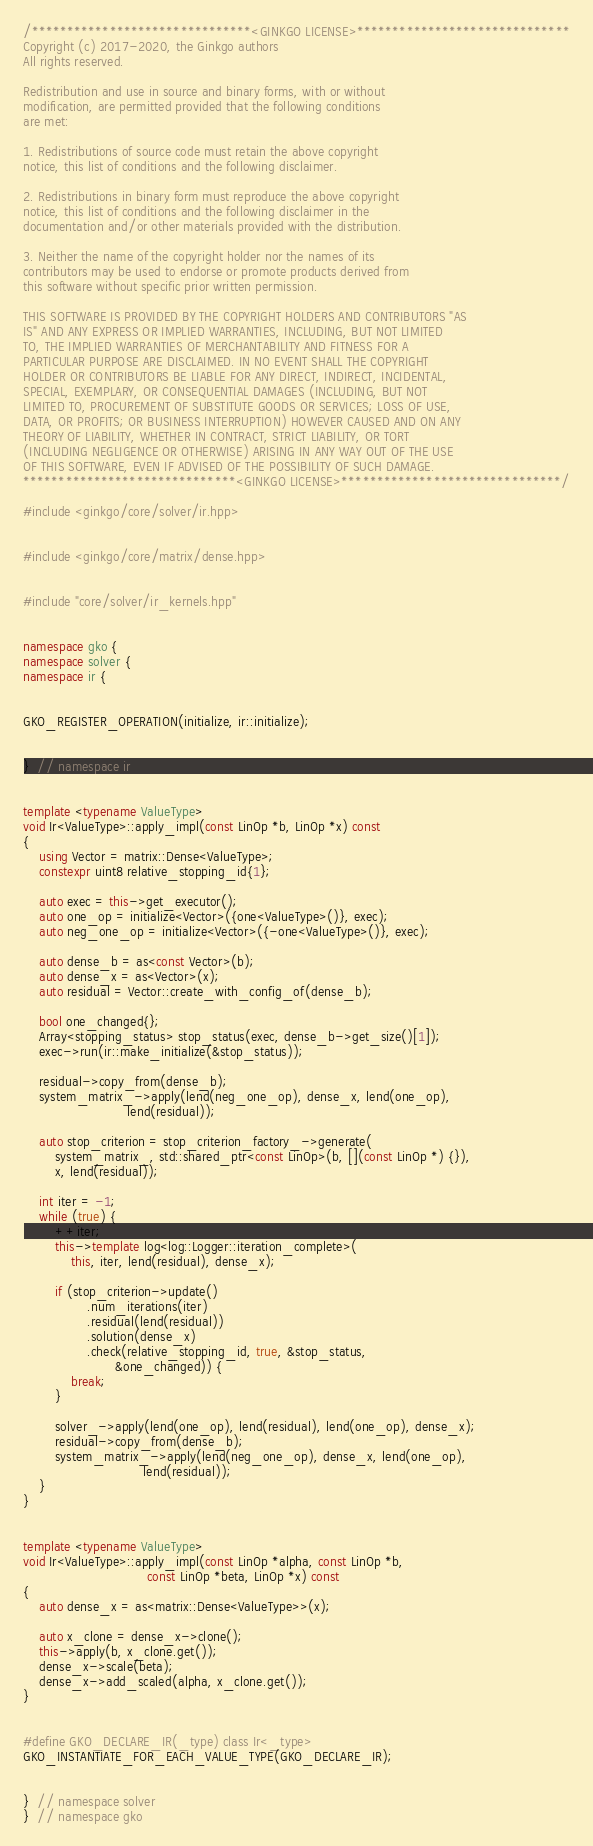<code> <loc_0><loc_0><loc_500><loc_500><_C++_>/*******************************<GINKGO LICENSE>******************************
Copyright (c) 2017-2020, the Ginkgo authors
All rights reserved.

Redistribution and use in source and binary forms, with or without
modification, are permitted provided that the following conditions
are met:

1. Redistributions of source code must retain the above copyright
notice, this list of conditions and the following disclaimer.

2. Redistributions in binary form must reproduce the above copyright
notice, this list of conditions and the following disclaimer in the
documentation and/or other materials provided with the distribution.

3. Neither the name of the copyright holder nor the names of its
contributors may be used to endorse or promote products derived from
this software without specific prior written permission.

THIS SOFTWARE IS PROVIDED BY THE COPYRIGHT HOLDERS AND CONTRIBUTORS "AS
IS" AND ANY EXPRESS OR IMPLIED WARRANTIES, INCLUDING, BUT NOT LIMITED
TO, THE IMPLIED WARRANTIES OF MERCHANTABILITY AND FITNESS FOR A
PARTICULAR PURPOSE ARE DISCLAIMED. IN NO EVENT SHALL THE COPYRIGHT
HOLDER OR CONTRIBUTORS BE LIABLE FOR ANY DIRECT, INDIRECT, INCIDENTAL,
SPECIAL, EXEMPLARY, OR CONSEQUENTIAL DAMAGES (INCLUDING, BUT NOT
LIMITED TO, PROCUREMENT OF SUBSTITUTE GOODS OR SERVICES; LOSS OF USE,
DATA, OR PROFITS; OR BUSINESS INTERRUPTION) HOWEVER CAUSED AND ON ANY
THEORY OF LIABILITY, WHETHER IN CONTRACT, STRICT LIABILITY, OR TORT
(INCLUDING NEGLIGENCE OR OTHERWISE) ARISING IN ANY WAY OUT OF THE USE
OF THIS SOFTWARE, EVEN IF ADVISED OF THE POSSIBILITY OF SUCH DAMAGE.
******************************<GINKGO LICENSE>*******************************/

#include <ginkgo/core/solver/ir.hpp>


#include <ginkgo/core/matrix/dense.hpp>


#include "core/solver/ir_kernels.hpp"


namespace gko {
namespace solver {
namespace ir {


GKO_REGISTER_OPERATION(initialize, ir::initialize);


}  // namespace ir


template <typename ValueType>
void Ir<ValueType>::apply_impl(const LinOp *b, LinOp *x) const
{
    using Vector = matrix::Dense<ValueType>;
    constexpr uint8 relative_stopping_id{1};

    auto exec = this->get_executor();
    auto one_op = initialize<Vector>({one<ValueType>()}, exec);
    auto neg_one_op = initialize<Vector>({-one<ValueType>()}, exec);

    auto dense_b = as<const Vector>(b);
    auto dense_x = as<Vector>(x);
    auto residual = Vector::create_with_config_of(dense_b);

    bool one_changed{};
    Array<stopping_status> stop_status(exec, dense_b->get_size()[1]);
    exec->run(ir::make_initialize(&stop_status));

    residual->copy_from(dense_b);
    system_matrix_->apply(lend(neg_one_op), dense_x, lend(one_op),
                          lend(residual));

    auto stop_criterion = stop_criterion_factory_->generate(
        system_matrix_, std::shared_ptr<const LinOp>(b, [](const LinOp *) {}),
        x, lend(residual));

    int iter = -1;
    while (true) {
        ++iter;
        this->template log<log::Logger::iteration_complete>(
            this, iter, lend(residual), dense_x);

        if (stop_criterion->update()
                .num_iterations(iter)
                .residual(lend(residual))
                .solution(dense_x)
                .check(relative_stopping_id, true, &stop_status,
                       &one_changed)) {
            break;
        }

        solver_->apply(lend(one_op), lend(residual), lend(one_op), dense_x);
        residual->copy_from(dense_b);
        system_matrix_->apply(lend(neg_one_op), dense_x, lend(one_op),
                              lend(residual));
    }
}


template <typename ValueType>
void Ir<ValueType>::apply_impl(const LinOp *alpha, const LinOp *b,
                               const LinOp *beta, LinOp *x) const
{
    auto dense_x = as<matrix::Dense<ValueType>>(x);

    auto x_clone = dense_x->clone();
    this->apply(b, x_clone.get());
    dense_x->scale(beta);
    dense_x->add_scaled(alpha, x_clone.get());
}


#define GKO_DECLARE_IR(_type) class Ir<_type>
GKO_INSTANTIATE_FOR_EACH_VALUE_TYPE(GKO_DECLARE_IR);


}  // namespace solver
}  // namespace gko
</code> 